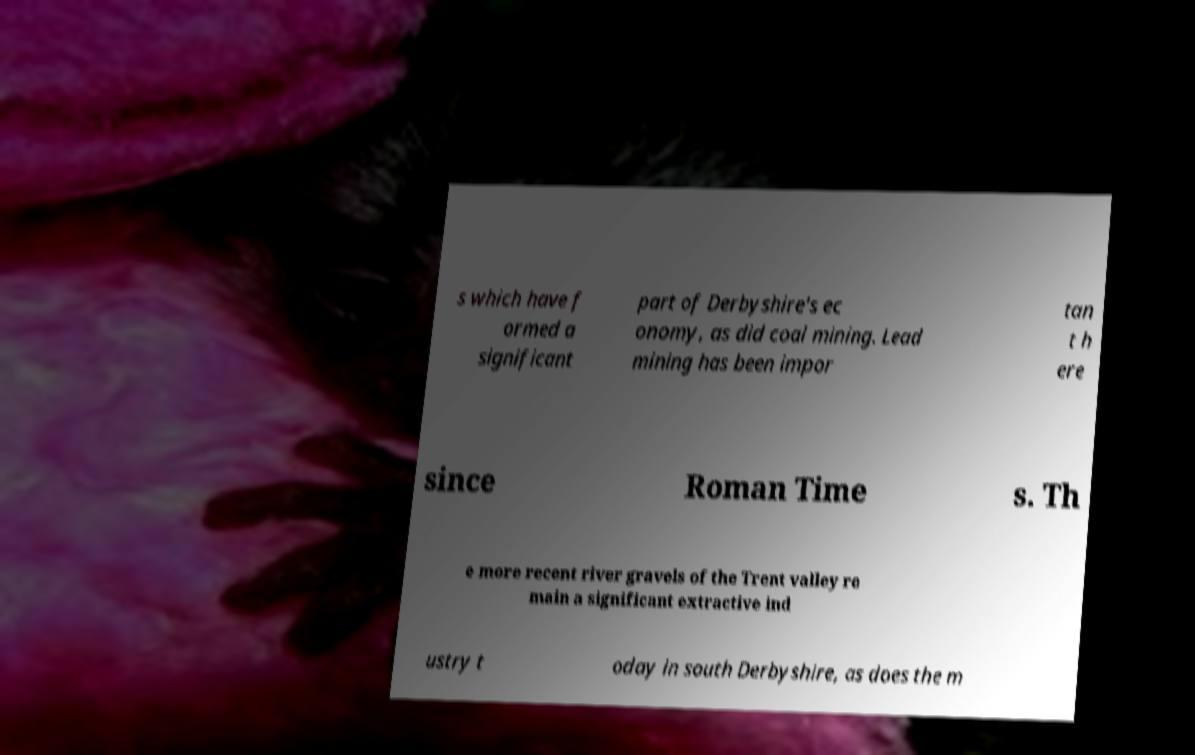For documentation purposes, I need the text within this image transcribed. Could you provide that? s which have f ormed a significant part of Derbyshire's ec onomy, as did coal mining. Lead mining has been impor tan t h ere since Roman Time s. Th e more recent river gravels of the Trent valley re main a significant extractive ind ustry t oday in south Derbyshire, as does the m 